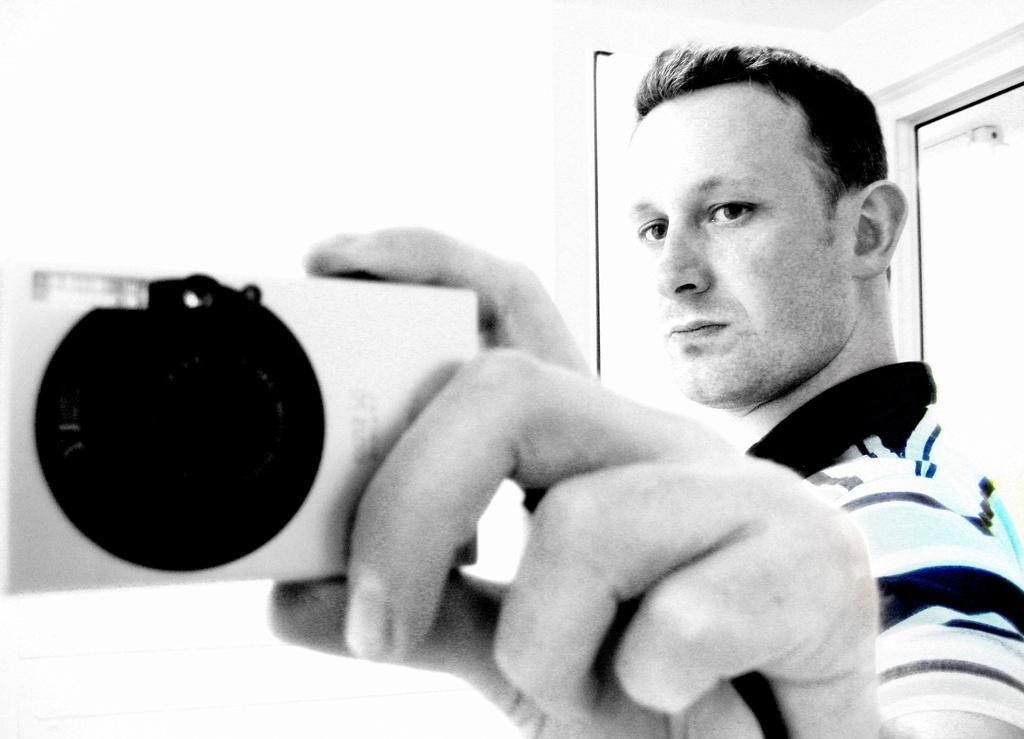Could you give a brief overview of what you see in this image? In this image in the foreground there is one man who is standing and he is holding a camera, in the background there is a door and a wall. 